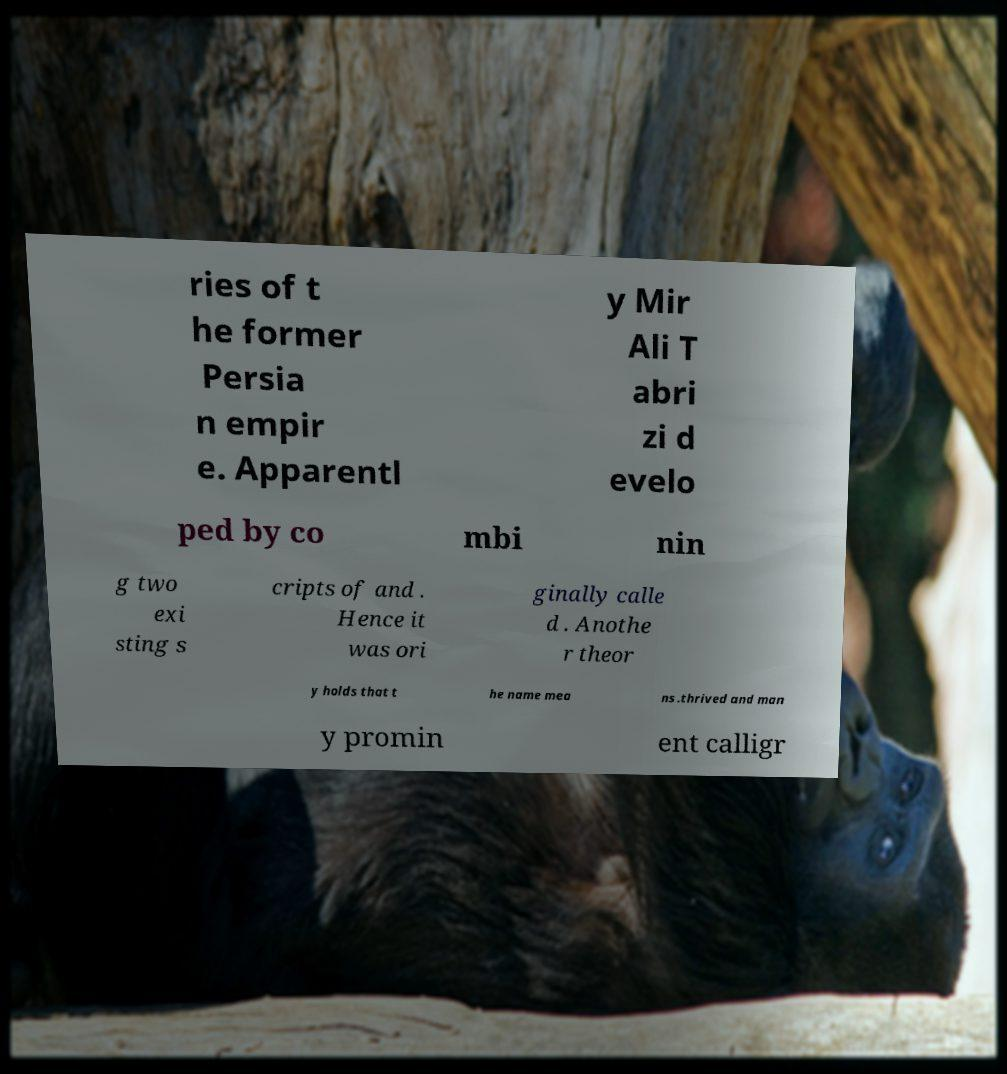Could you extract and type out the text from this image? ries of t he former Persia n empir e. Apparentl y Mir Ali T abri zi d evelo ped by co mbi nin g two exi sting s cripts of and . Hence it was ori ginally calle d . Anothe r theor y holds that t he name mea ns .thrived and man y promin ent calligr 